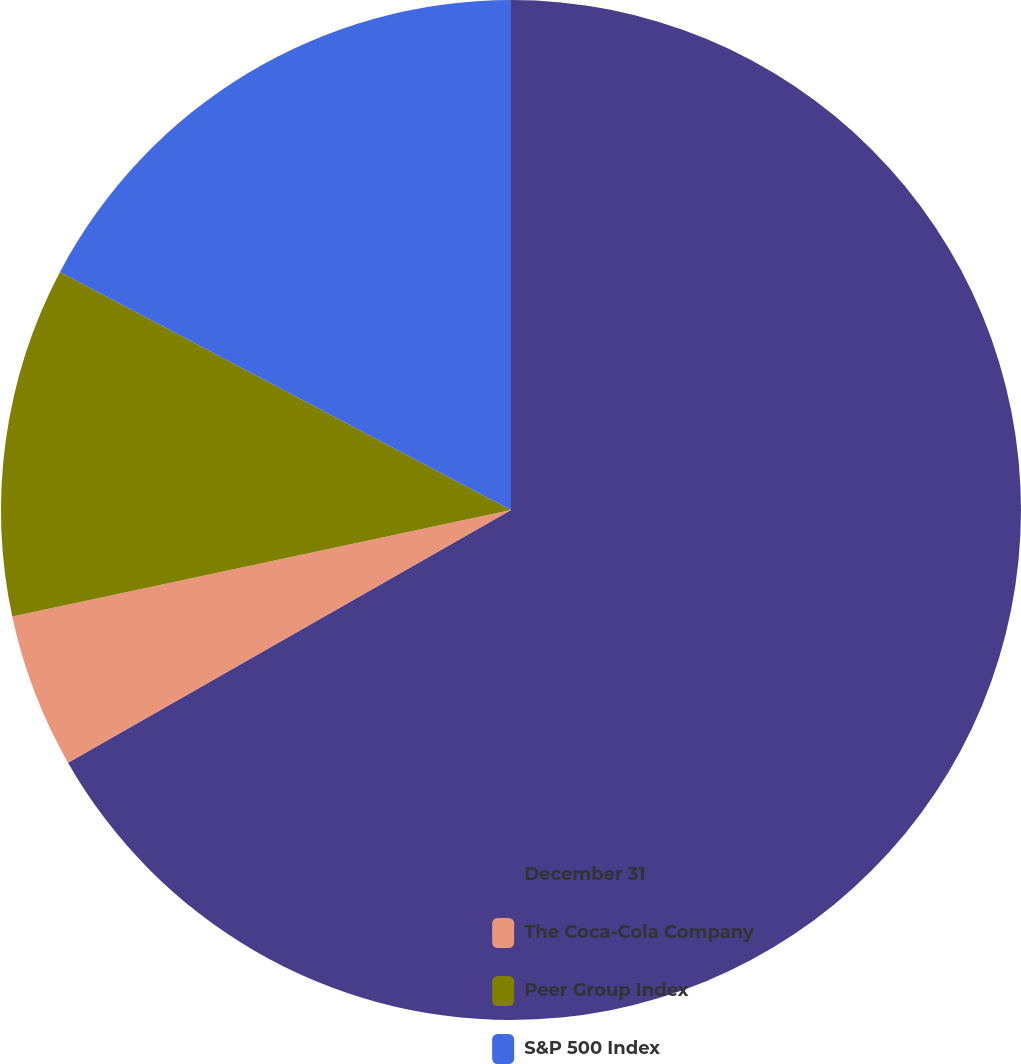Convert chart. <chart><loc_0><loc_0><loc_500><loc_500><pie_chart><fcel>December 31<fcel>The Coca-Cola Company<fcel>Peer Group Index<fcel>S&P 500 Index<nl><fcel>66.75%<fcel>4.9%<fcel>11.08%<fcel>17.27%<nl></chart> 